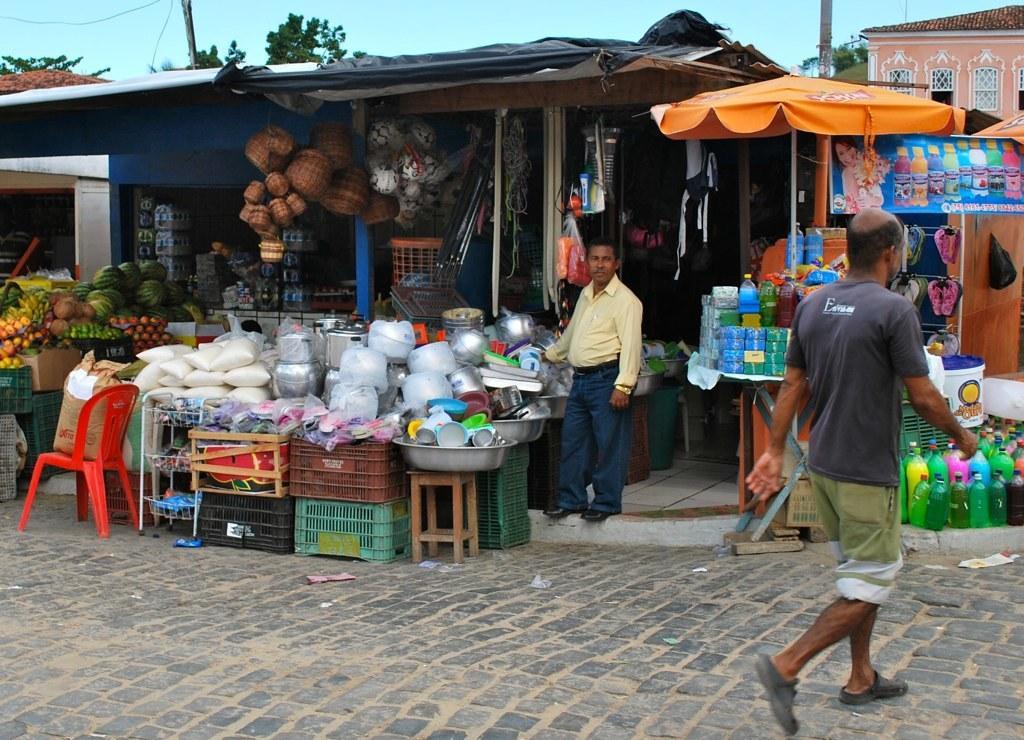In one or two sentences, can you explain what this image depicts? In this picture we can see a man who is standing on the floor. This is the stall. Here we can see some vegetables and fruits. This is the chair. There are some vessels. These are the baskets. Here we can see a person who is crossing the road. And these are the bottles. On the background we can see the sky. And this is the tree. 